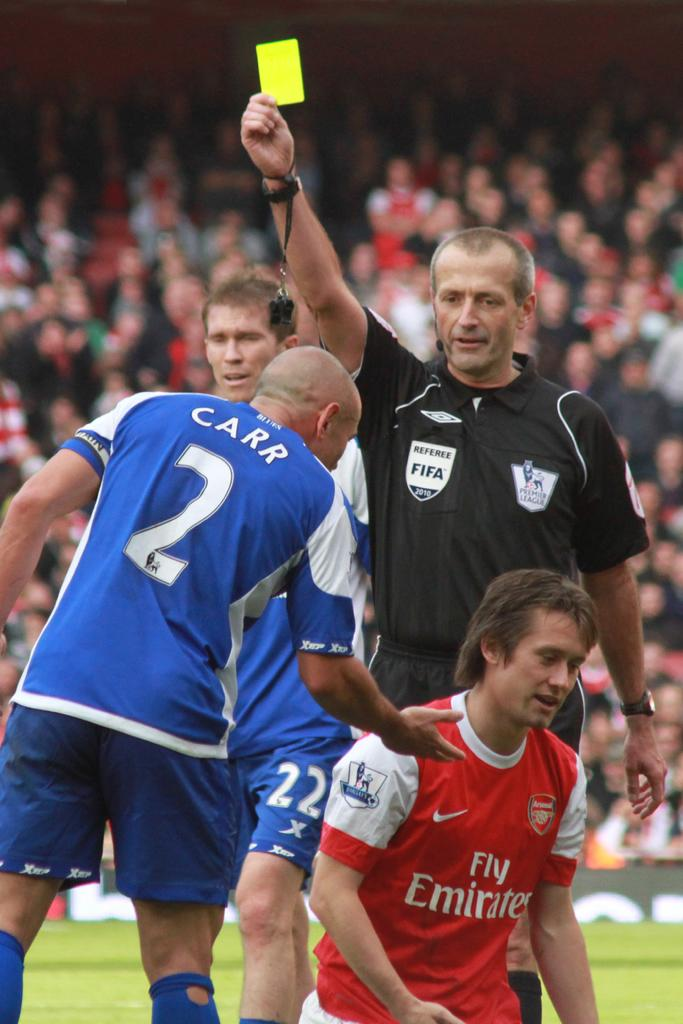Provide a one-sentence caption for the provided image. A referee from Fifa gives out a yellow card while player, Carr, puts his hand towards the opposing team member. 